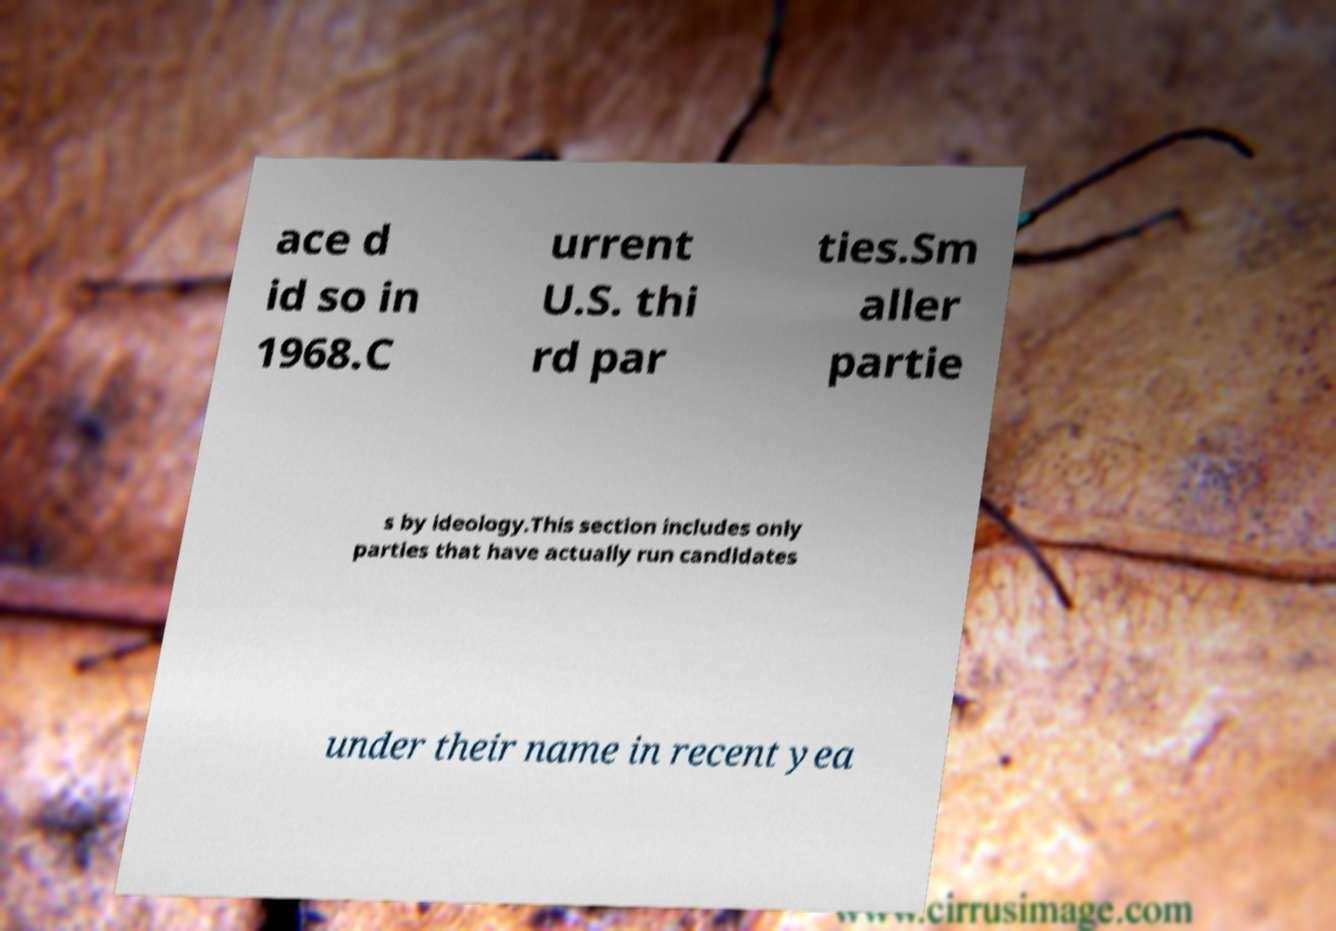There's text embedded in this image that I need extracted. Can you transcribe it verbatim? ace d id so in 1968.C urrent U.S. thi rd par ties.Sm aller partie s by ideology.This section includes only parties that have actually run candidates under their name in recent yea 